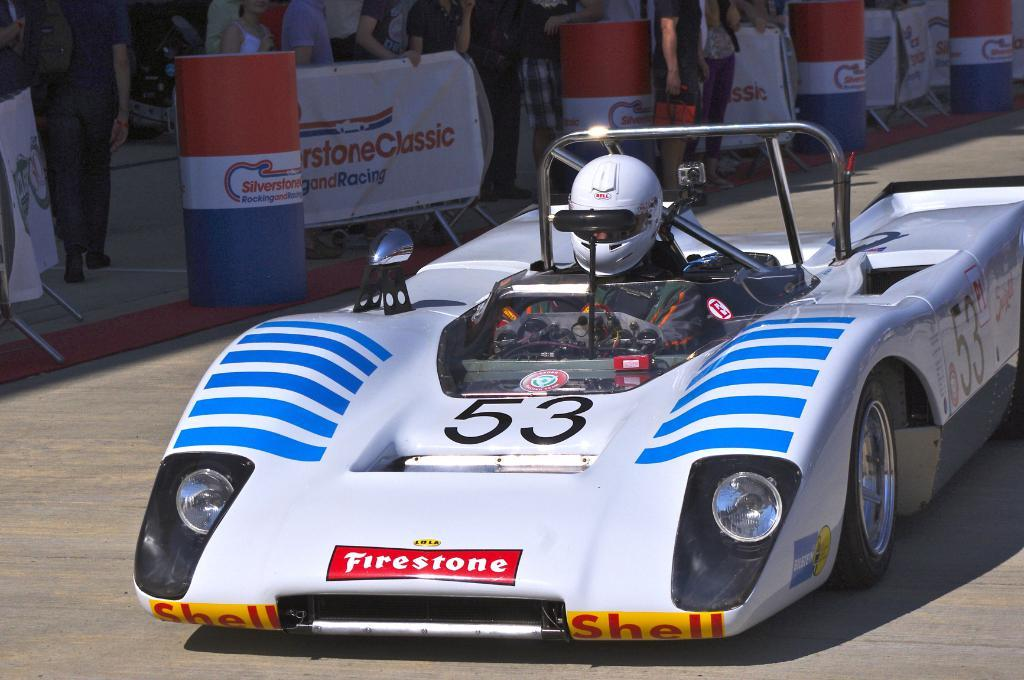What is the person in the image doing? The person is sitting in a car. What protective gear is the person wearing? The person is wearing a helmet. Can you describe the people in the background of the image? There are people standing in the background of the image. What type of interest does the goldfish have in the car? There is no goldfish present in the image, so it cannot have any interest in the car. 